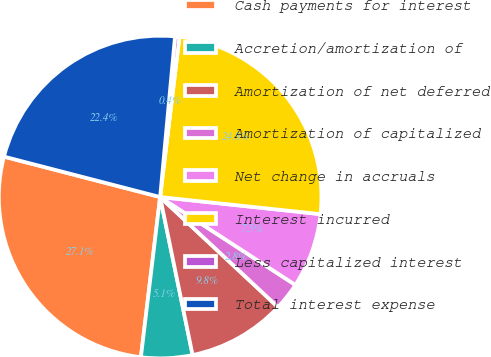Convert chart to OTSL. <chart><loc_0><loc_0><loc_500><loc_500><pie_chart><fcel>Cash payments for interest<fcel>Accretion/amortization of<fcel>Amortization of net deferred<fcel>Amortization of capitalized<fcel>Net change in accruals<fcel>Interest incurred<fcel>Less capitalized interest<fcel>Total interest expense<nl><fcel>27.13%<fcel>5.13%<fcel>9.82%<fcel>2.78%<fcel>7.48%<fcel>24.78%<fcel>0.44%<fcel>22.44%<nl></chart> 